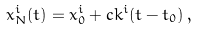Convert formula to latex. <formula><loc_0><loc_0><loc_500><loc_500>x ^ { i } _ { N } ( t ) = x ^ { i } _ { 0 } + c k ^ { i } ( t - t _ { 0 } ) \, ,</formula> 